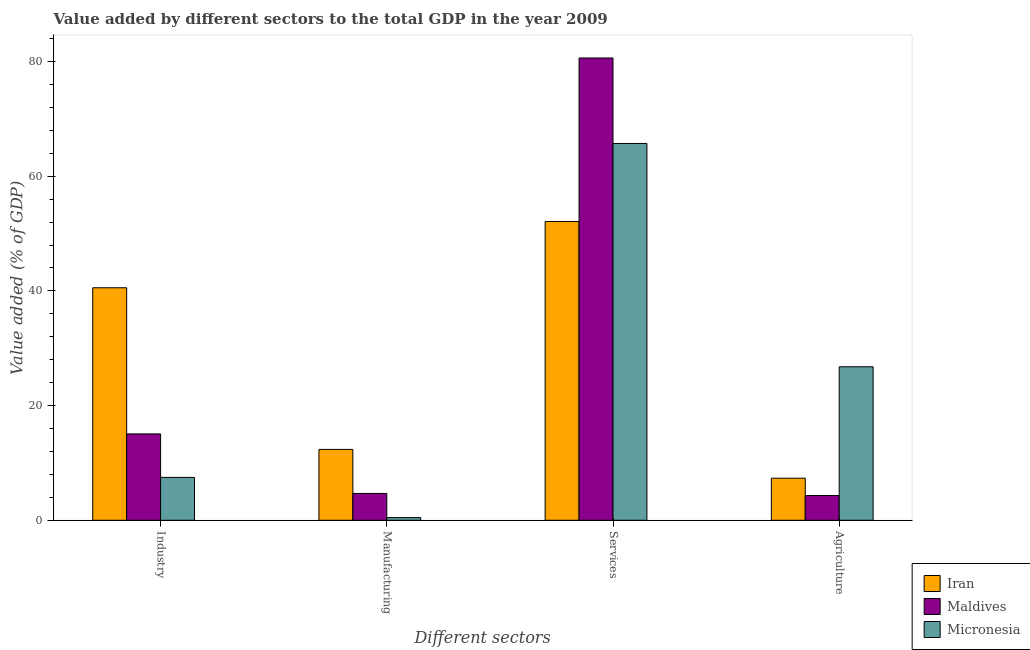How many groups of bars are there?
Offer a terse response. 4. How many bars are there on the 3rd tick from the right?
Make the answer very short. 3. What is the label of the 3rd group of bars from the left?
Provide a short and direct response. Services. What is the value added by agricultural sector in Maldives?
Make the answer very short. 4.31. Across all countries, what is the maximum value added by services sector?
Offer a terse response. 80.62. Across all countries, what is the minimum value added by industrial sector?
Ensure brevity in your answer.  7.48. In which country was the value added by industrial sector maximum?
Ensure brevity in your answer.  Iran. In which country was the value added by services sector minimum?
Keep it short and to the point. Iran. What is the total value added by agricultural sector in the graph?
Provide a short and direct response. 38.42. What is the difference between the value added by industrial sector in Iran and that in Maldives?
Provide a short and direct response. 25.49. What is the difference between the value added by manufacturing sector in Iran and the value added by agricultural sector in Maldives?
Your answer should be compact. 8.04. What is the average value added by industrial sector per country?
Provide a succinct answer. 21.03. What is the difference between the value added by agricultural sector and value added by industrial sector in Micronesia?
Make the answer very short. 19.3. In how many countries, is the value added by agricultural sector greater than 20 %?
Make the answer very short. 1. What is the ratio of the value added by industrial sector in Iran to that in Maldives?
Ensure brevity in your answer.  2.69. Is the difference between the value added by agricultural sector in Micronesia and Iran greater than the difference between the value added by industrial sector in Micronesia and Iran?
Offer a terse response. Yes. What is the difference between the highest and the second highest value added by industrial sector?
Your response must be concise. 25.49. What is the difference between the highest and the lowest value added by services sector?
Offer a terse response. 28.51. In how many countries, is the value added by manufacturing sector greater than the average value added by manufacturing sector taken over all countries?
Ensure brevity in your answer.  1. Is the sum of the value added by agricultural sector in Iran and Micronesia greater than the maximum value added by industrial sector across all countries?
Make the answer very short. No. What does the 3rd bar from the left in Services represents?
Provide a short and direct response. Micronesia. What does the 1st bar from the right in Services represents?
Keep it short and to the point. Micronesia. Is it the case that in every country, the sum of the value added by industrial sector and value added by manufacturing sector is greater than the value added by services sector?
Offer a terse response. No. What is the difference between two consecutive major ticks on the Y-axis?
Offer a terse response. 20. Does the graph contain grids?
Give a very brief answer. No. How many legend labels are there?
Your answer should be very brief. 3. What is the title of the graph?
Give a very brief answer. Value added by different sectors to the total GDP in the year 2009. What is the label or title of the X-axis?
Make the answer very short. Different sectors. What is the label or title of the Y-axis?
Offer a terse response. Value added (% of GDP). What is the Value added (% of GDP) of Iran in Industry?
Offer a very short reply. 40.55. What is the Value added (% of GDP) in Maldives in Industry?
Your answer should be compact. 15.06. What is the Value added (% of GDP) in Micronesia in Industry?
Make the answer very short. 7.48. What is the Value added (% of GDP) in Iran in Manufacturing?
Your answer should be very brief. 12.36. What is the Value added (% of GDP) in Maldives in Manufacturing?
Offer a very short reply. 4.68. What is the Value added (% of GDP) of Micronesia in Manufacturing?
Provide a succinct answer. 0.47. What is the Value added (% of GDP) in Iran in Services?
Make the answer very short. 52.11. What is the Value added (% of GDP) of Maldives in Services?
Provide a short and direct response. 80.62. What is the Value added (% of GDP) in Micronesia in Services?
Keep it short and to the point. 65.72. What is the Value added (% of GDP) of Iran in Agriculture?
Give a very brief answer. 7.34. What is the Value added (% of GDP) in Maldives in Agriculture?
Make the answer very short. 4.31. What is the Value added (% of GDP) in Micronesia in Agriculture?
Keep it short and to the point. 26.77. Across all Different sectors, what is the maximum Value added (% of GDP) of Iran?
Ensure brevity in your answer.  52.11. Across all Different sectors, what is the maximum Value added (% of GDP) in Maldives?
Your response must be concise. 80.62. Across all Different sectors, what is the maximum Value added (% of GDP) in Micronesia?
Make the answer very short. 65.72. Across all Different sectors, what is the minimum Value added (% of GDP) in Iran?
Provide a short and direct response. 7.34. Across all Different sectors, what is the minimum Value added (% of GDP) in Maldives?
Your answer should be very brief. 4.31. Across all Different sectors, what is the minimum Value added (% of GDP) in Micronesia?
Provide a short and direct response. 0.47. What is the total Value added (% of GDP) of Iran in the graph?
Provide a short and direct response. 112.36. What is the total Value added (% of GDP) in Maldives in the graph?
Your answer should be very brief. 104.68. What is the total Value added (% of GDP) of Micronesia in the graph?
Your answer should be very brief. 100.43. What is the difference between the Value added (% of GDP) of Iran in Industry and that in Manufacturing?
Keep it short and to the point. 28.19. What is the difference between the Value added (% of GDP) of Maldives in Industry and that in Manufacturing?
Offer a very short reply. 10.38. What is the difference between the Value added (% of GDP) in Micronesia in Industry and that in Manufacturing?
Ensure brevity in your answer.  7.01. What is the difference between the Value added (% of GDP) in Iran in Industry and that in Services?
Provide a succinct answer. -11.56. What is the difference between the Value added (% of GDP) of Maldives in Industry and that in Services?
Your answer should be very brief. -65.56. What is the difference between the Value added (% of GDP) of Micronesia in Industry and that in Services?
Keep it short and to the point. -58.24. What is the difference between the Value added (% of GDP) in Iran in Industry and that in Agriculture?
Your response must be concise. 33.22. What is the difference between the Value added (% of GDP) of Maldives in Industry and that in Agriculture?
Keep it short and to the point. 10.75. What is the difference between the Value added (% of GDP) in Micronesia in Industry and that in Agriculture?
Ensure brevity in your answer.  -19.3. What is the difference between the Value added (% of GDP) of Iran in Manufacturing and that in Services?
Make the answer very short. -39.75. What is the difference between the Value added (% of GDP) in Maldives in Manufacturing and that in Services?
Your answer should be compact. -75.95. What is the difference between the Value added (% of GDP) of Micronesia in Manufacturing and that in Services?
Offer a terse response. -65.25. What is the difference between the Value added (% of GDP) of Iran in Manufacturing and that in Agriculture?
Ensure brevity in your answer.  5.02. What is the difference between the Value added (% of GDP) in Maldives in Manufacturing and that in Agriculture?
Give a very brief answer. 0.36. What is the difference between the Value added (% of GDP) in Micronesia in Manufacturing and that in Agriculture?
Keep it short and to the point. -26.3. What is the difference between the Value added (% of GDP) of Iran in Services and that in Agriculture?
Keep it short and to the point. 44.77. What is the difference between the Value added (% of GDP) of Maldives in Services and that in Agriculture?
Make the answer very short. 76.31. What is the difference between the Value added (% of GDP) in Micronesia in Services and that in Agriculture?
Ensure brevity in your answer.  38.94. What is the difference between the Value added (% of GDP) in Iran in Industry and the Value added (% of GDP) in Maldives in Manufacturing?
Make the answer very short. 35.87. What is the difference between the Value added (% of GDP) of Iran in Industry and the Value added (% of GDP) of Micronesia in Manufacturing?
Make the answer very short. 40.08. What is the difference between the Value added (% of GDP) of Maldives in Industry and the Value added (% of GDP) of Micronesia in Manufacturing?
Offer a very short reply. 14.59. What is the difference between the Value added (% of GDP) of Iran in Industry and the Value added (% of GDP) of Maldives in Services?
Make the answer very short. -40.07. What is the difference between the Value added (% of GDP) in Iran in Industry and the Value added (% of GDP) in Micronesia in Services?
Provide a succinct answer. -25.16. What is the difference between the Value added (% of GDP) in Maldives in Industry and the Value added (% of GDP) in Micronesia in Services?
Keep it short and to the point. -50.65. What is the difference between the Value added (% of GDP) in Iran in Industry and the Value added (% of GDP) in Maldives in Agriculture?
Offer a very short reply. 36.24. What is the difference between the Value added (% of GDP) of Iran in Industry and the Value added (% of GDP) of Micronesia in Agriculture?
Ensure brevity in your answer.  13.78. What is the difference between the Value added (% of GDP) in Maldives in Industry and the Value added (% of GDP) in Micronesia in Agriculture?
Provide a short and direct response. -11.71. What is the difference between the Value added (% of GDP) of Iran in Manufacturing and the Value added (% of GDP) of Maldives in Services?
Provide a succinct answer. -68.27. What is the difference between the Value added (% of GDP) in Iran in Manufacturing and the Value added (% of GDP) in Micronesia in Services?
Give a very brief answer. -53.36. What is the difference between the Value added (% of GDP) in Maldives in Manufacturing and the Value added (% of GDP) in Micronesia in Services?
Make the answer very short. -61.04. What is the difference between the Value added (% of GDP) of Iran in Manufacturing and the Value added (% of GDP) of Maldives in Agriculture?
Keep it short and to the point. 8.04. What is the difference between the Value added (% of GDP) of Iran in Manufacturing and the Value added (% of GDP) of Micronesia in Agriculture?
Provide a succinct answer. -14.41. What is the difference between the Value added (% of GDP) in Maldives in Manufacturing and the Value added (% of GDP) in Micronesia in Agriculture?
Offer a very short reply. -22.09. What is the difference between the Value added (% of GDP) in Iran in Services and the Value added (% of GDP) in Maldives in Agriculture?
Offer a terse response. 47.8. What is the difference between the Value added (% of GDP) of Iran in Services and the Value added (% of GDP) of Micronesia in Agriculture?
Provide a succinct answer. 25.34. What is the difference between the Value added (% of GDP) of Maldives in Services and the Value added (% of GDP) of Micronesia in Agriculture?
Your answer should be very brief. 53.85. What is the average Value added (% of GDP) of Iran per Different sectors?
Your answer should be compact. 28.09. What is the average Value added (% of GDP) of Maldives per Different sectors?
Make the answer very short. 26.17. What is the average Value added (% of GDP) of Micronesia per Different sectors?
Offer a very short reply. 25.11. What is the difference between the Value added (% of GDP) in Iran and Value added (% of GDP) in Maldives in Industry?
Your response must be concise. 25.49. What is the difference between the Value added (% of GDP) of Iran and Value added (% of GDP) of Micronesia in Industry?
Provide a short and direct response. 33.08. What is the difference between the Value added (% of GDP) in Maldives and Value added (% of GDP) in Micronesia in Industry?
Keep it short and to the point. 7.59. What is the difference between the Value added (% of GDP) of Iran and Value added (% of GDP) of Maldives in Manufacturing?
Your answer should be compact. 7.68. What is the difference between the Value added (% of GDP) of Iran and Value added (% of GDP) of Micronesia in Manufacturing?
Offer a very short reply. 11.89. What is the difference between the Value added (% of GDP) of Maldives and Value added (% of GDP) of Micronesia in Manufacturing?
Ensure brevity in your answer.  4.21. What is the difference between the Value added (% of GDP) in Iran and Value added (% of GDP) in Maldives in Services?
Provide a short and direct response. -28.51. What is the difference between the Value added (% of GDP) in Iran and Value added (% of GDP) in Micronesia in Services?
Keep it short and to the point. -13.61. What is the difference between the Value added (% of GDP) in Maldives and Value added (% of GDP) in Micronesia in Services?
Give a very brief answer. 14.91. What is the difference between the Value added (% of GDP) of Iran and Value added (% of GDP) of Maldives in Agriculture?
Provide a succinct answer. 3.02. What is the difference between the Value added (% of GDP) in Iran and Value added (% of GDP) in Micronesia in Agriculture?
Keep it short and to the point. -19.43. What is the difference between the Value added (% of GDP) in Maldives and Value added (% of GDP) in Micronesia in Agriculture?
Your response must be concise. -22.46. What is the ratio of the Value added (% of GDP) of Iran in Industry to that in Manufacturing?
Make the answer very short. 3.28. What is the ratio of the Value added (% of GDP) of Maldives in Industry to that in Manufacturing?
Your answer should be very brief. 3.22. What is the ratio of the Value added (% of GDP) in Micronesia in Industry to that in Manufacturing?
Keep it short and to the point. 15.92. What is the ratio of the Value added (% of GDP) of Iran in Industry to that in Services?
Keep it short and to the point. 0.78. What is the ratio of the Value added (% of GDP) in Maldives in Industry to that in Services?
Ensure brevity in your answer.  0.19. What is the ratio of the Value added (% of GDP) of Micronesia in Industry to that in Services?
Provide a succinct answer. 0.11. What is the ratio of the Value added (% of GDP) of Iran in Industry to that in Agriculture?
Make the answer very short. 5.53. What is the ratio of the Value added (% of GDP) of Maldives in Industry to that in Agriculture?
Your answer should be very brief. 3.49. What is the ratio of the Value added (% of GDP) of Micronesia in Industry to that in Agriculture?
Offer a terse response. 0.28. What is the ratio of the Value added (% of GDP) in Iran in Manufacturing to that in Services?
Your answer should be very brief. 0.24. What is the ratio of the Value added (% of GDP) in Maldives in Manufacturing to that in Services?
Offer a very short reply. 0.06. What is the ratio of the Value added (% of GDP) of Micronesia in Manufacturing to that in Services?
Your answer should be compact. 0.01. What is the ratio of the Value added (% of GDP) of Iran in Manufacturing to that in Agriculture?
Keep it short and to the point. 1.68. What is the ratio of the Value added (% of GDP) in Maldives in Manufacturing to that in Agriculture?
Offer a very short reply. 1.08. What is the ratio of the Value added (% of GDP) of Micronesia in Manufacturing to that in Agriculture?
Your response must be concise. 0.02. What is the ratio of the Value added (% of GDP) in Iran in Services to that in Agriculture?
Provide a succinct answer. 7.1. What is the ratio of the Value added (% of GDP) in Maldives in Services to that in Agriculture?
Your response must be concise. 18.69. What is the ratio of the Value added (% of GDP) of Micronesia in Services to that in Agriculture?
Your answer should be compact. 2.45. What is the difference between the highest and the second highest Value added (% of GDP) of Iran?
Offer a terse response. 11.56. What is the difference between the highest and the second highest Value added (% of GDP) in Maldives?
Ensure brevity in your answer.  65.56. What is the difference between the highest and the second highest Value added (% of GDP) of Micronesia?
Your response must be concise. 38.94. What is the difference between the highest and the lowest Value added (% of GDP) in Iran?
Make the answer very short. 44.77. What is the difference between the highest and the lowest Value added (% of GDP) in Maldives?
Your answer should be very brief. 76.31. What is the difference between the highest and the lowest Value added (% of GDP) of Micronesia?
Your answer should be very brief. 65.25. 